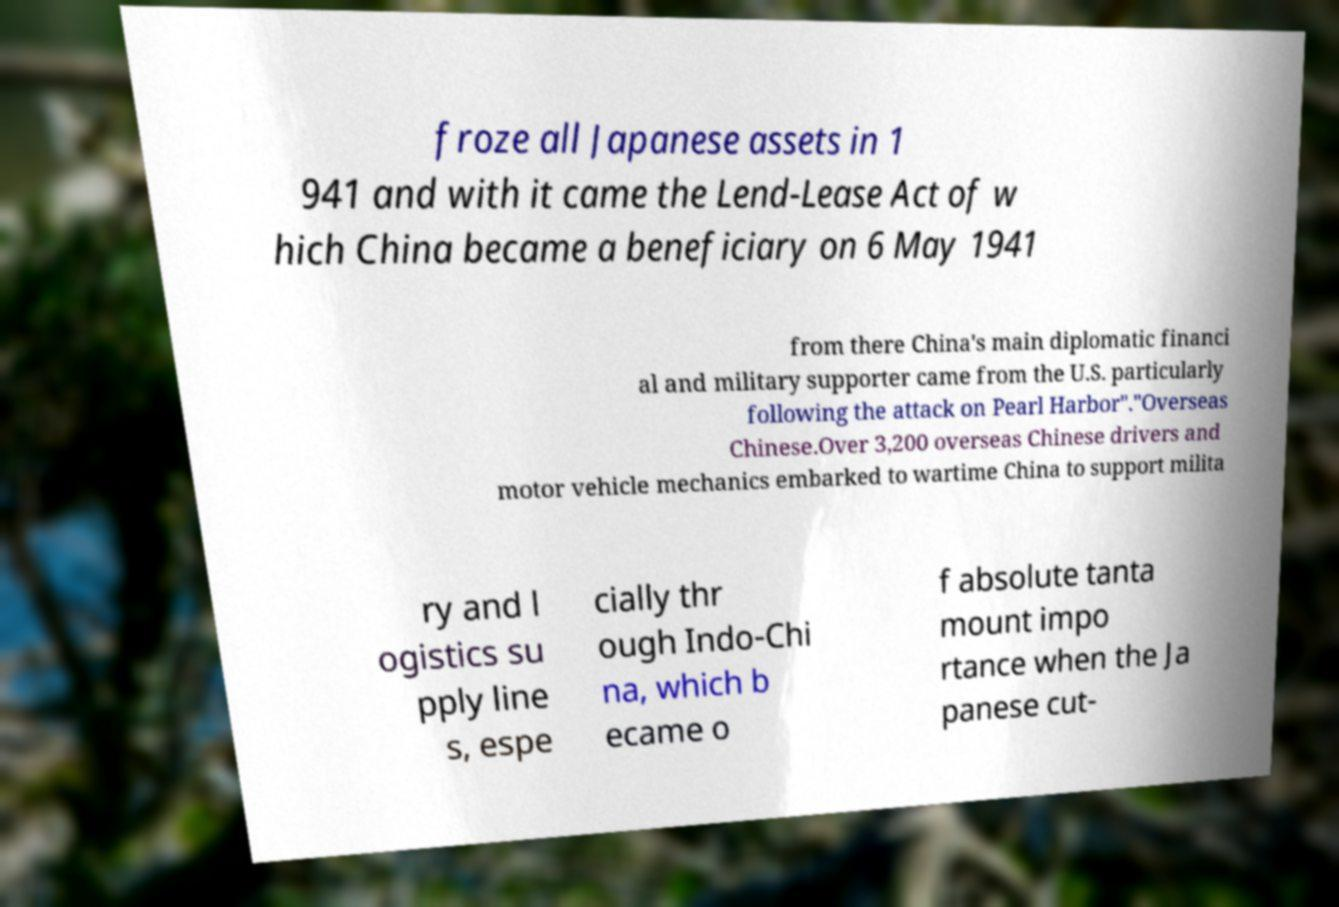Could you assist in decoding the text presented in this image and type it out clearly? froze all Japanese assets in 1 941 and with it came the Lend-Lease Act of w hich China became a beneficiary on 6 May 1941 from there China's main diplomatic financi al and military supporter came from the U.S. particularly following the attack on Pearl Harbor"."Overseas Chinese.Over 3,200 overseas Chinese drivers and motor vehicle mechanics embarked to wartime China to support milita ry and l ogistics su pply line s, espe cially thr ough Indo-Chi na, which b ecame o f absolute tanta mount impo rtance when the Ja panese cut- 